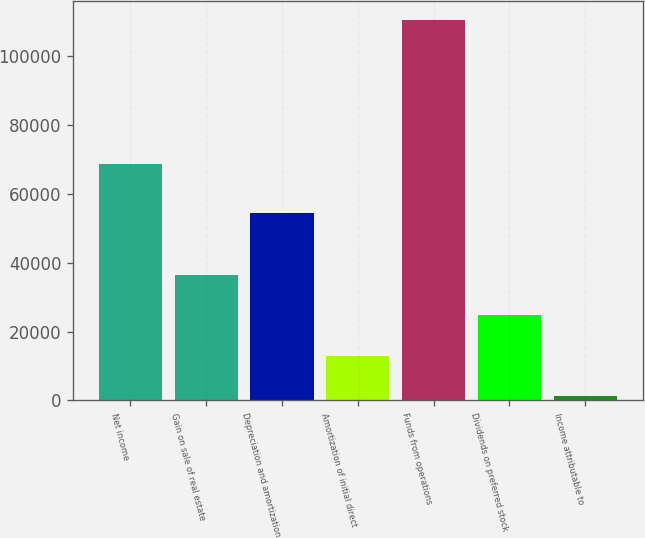Convert chart to OTSL. <chart><loc_0><loc_0><loc_500><loc_500><bar_chart><fcel>Net income<fcel>Gain on sale of real estate<fcel>Depreciation and amortization<fcel>Amortization of initial direct<fcel>Funds from operations<fcel>Dividends on preferred stock<fcel>Income attributable to<nl><fcel>68756<fcel>36393.4<fcel>54350<fcel>13053.8<fcel>110432<fcel>24723.6<fcel>1384<nl></chart> 